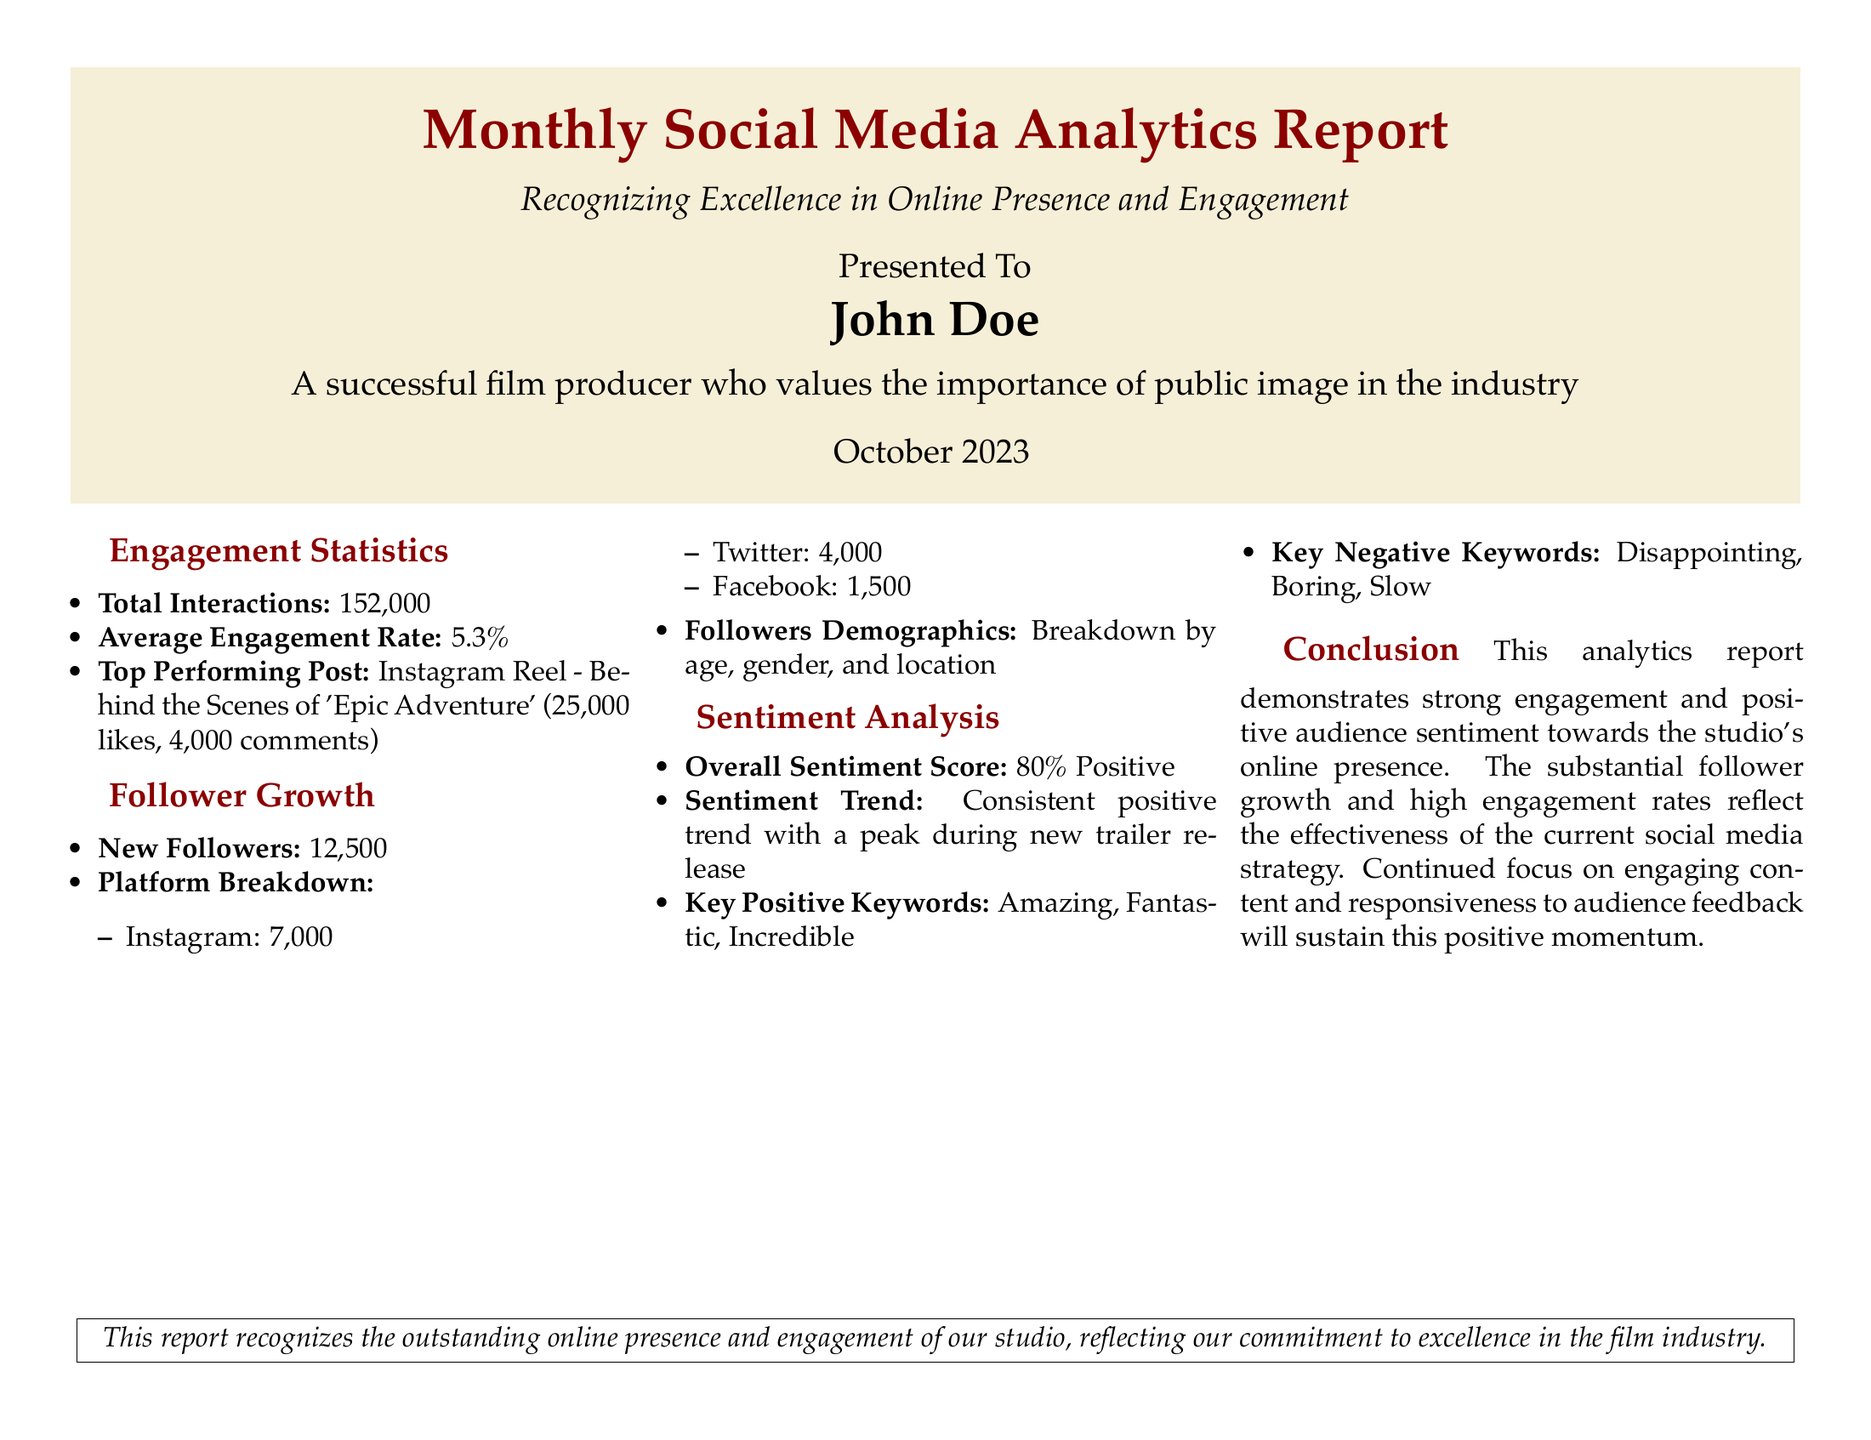What is the total number of interactions? The total number of interactions is stated directly in the document as 152,000.
Answer: 152,000 What is the average engagement rate? The average engagement rate is provided in the engagement statistics section, which states it is 5.3%.
Answer: 5.3% How many new followers were gained? The document specifies that the number of new followers gained is 12,500.
Answer: 12,500 What is the overall sentiment score? The overall sentiment score reflects the audience's feelings and is reported as 80% Positive.
Answer: 80% Positive Which was the top-performing post? The top-performing post is mentioned in the engagement statistics and is identified as an Instagram Reel of 'Epic Adventure'.
Answer: Instagram Reel - Behind the Scenes of 'Epic Adventure' Why has the engagement rate been effective? The document cites that the high engagement rates reflect the effectiveness of the current social media strategy, implying positive audience reception.
Answer: Current social media strategy What was the sentiment trend during the new trailer release? The document indicates that there was a consistent positive trend with a peak during the new trailer release, highlighting the effect of promotional content.
Answer: Consistent positive trend How many new followers did Instagram account for? The platform breakdown shows that 7,000 new followers were gained on Instagram.
Answer: 7,000 What are the key negative keywords? The document lists key negative keywords, which include disappointing, boring, and slow.
Answer: Disappointing, Boring, Slow 